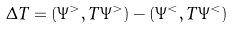<formula> <loc_0><loc_0><loc_500><loc_500>\Delta T = ( \Psi ^ { > } , \hat { T } \Psi ^ { > } ) - ( \Psi ^ { < } , \hat { T } \Psi ^ { < } )</formula> 